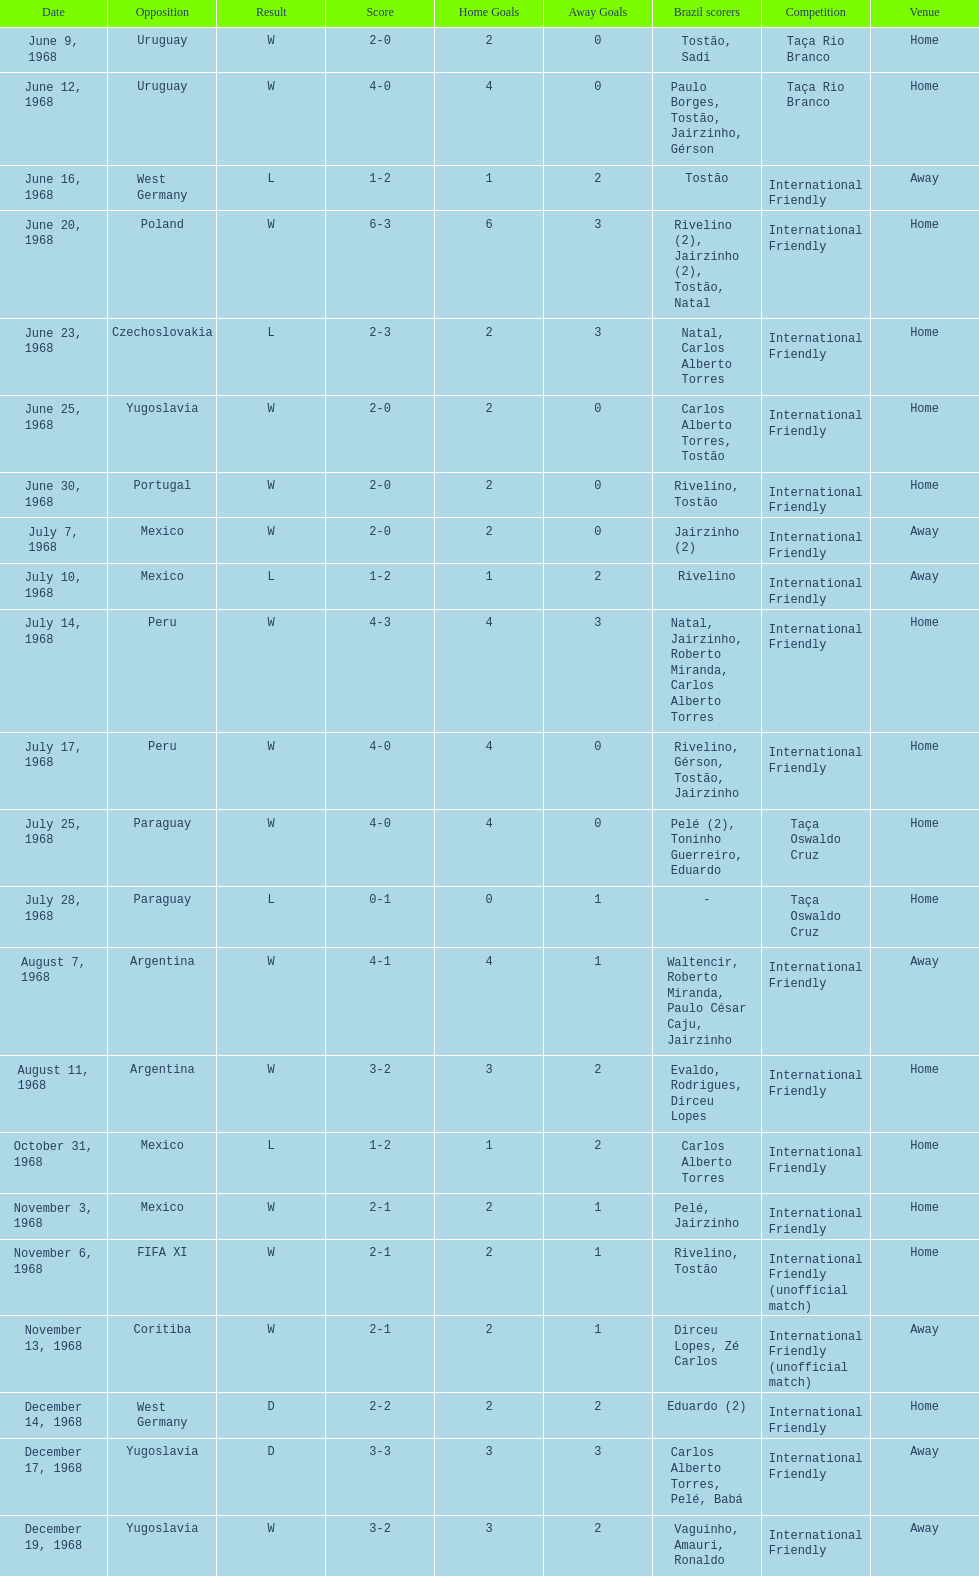Total number of wins 15. 